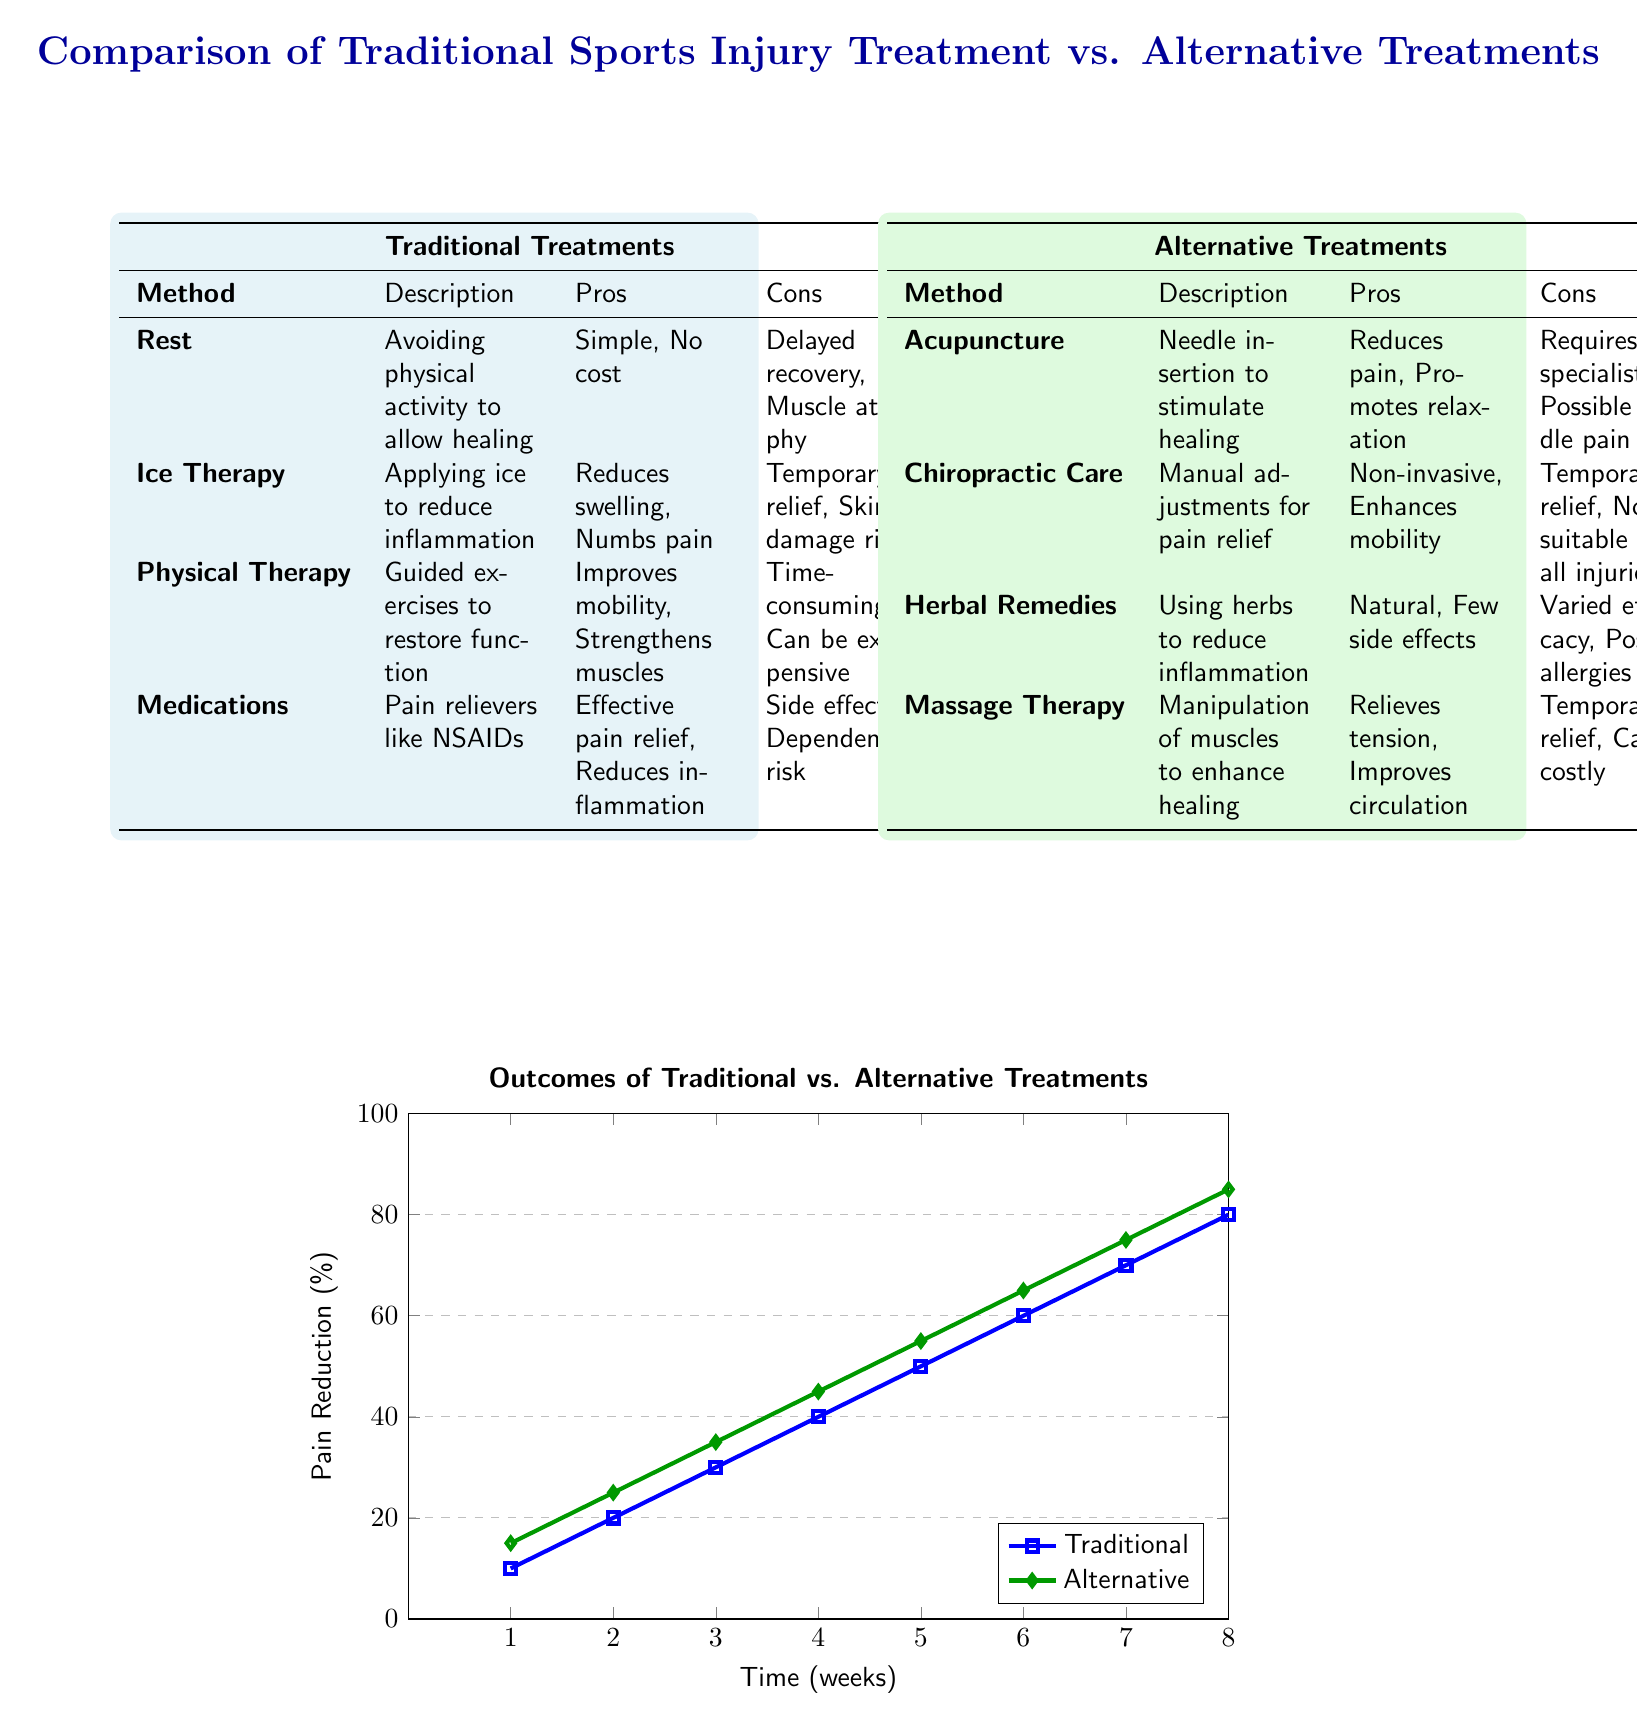What is the first traditional treatment listed in the left table? The left table under "Traditional Treatments" shows "Rest" as the first method listed in the first row after the headers.
Answer: Rest What is the pros of Ice Therapy? Referring to the traditional treatments table, the pros of Ice Therapy indicate it "Reduces swelling, Numbs pain".
Answer: Reduces swelling, Numbs pain Which alternative treatment has the least risk of side effects? In the alternative treatments table, "Herbal Remedies" are mentioned to have "Natural, Few side effects", suggesting the least risk among the options.
Answer: Herbal Remedies What percentage of pain reduction is achieved at 6 weeks with traditional treatment? The outcomes graph indicates that at 6 weeks, the pain reduction for traditional treatments is 60%.
Answer: 60 How does the pain reduction of alternative treatments at week 8 compare to traditional treatments? From the outcomes graph, at week 8, alternative treatments result in an 85% pain reduction while traditional treatments reach 80%, showing that alternative treatments provide slightly more pain relief.
Answer: Higher What is the total number of traditional and alternative treatments listed in the diagram? The traditional treatments list contains four methods, and the alternative treatments list also contains four methods, summing to eight treatments in total.
Answer: Eight Which table has a method that requires a specialist? The alternative treatments table contains "Acupuncture", which is stated to require a specialist, while the traditional treatments table does not have this mention.
Answer: Alternative Treatments What is the main con of Physical Therapy listed in the diagram? In the traditional treatments table, the con of Physical Therapy is described as "Time-consuming, Can be expensive".
Answer: Time-consuming, Can be expensive 